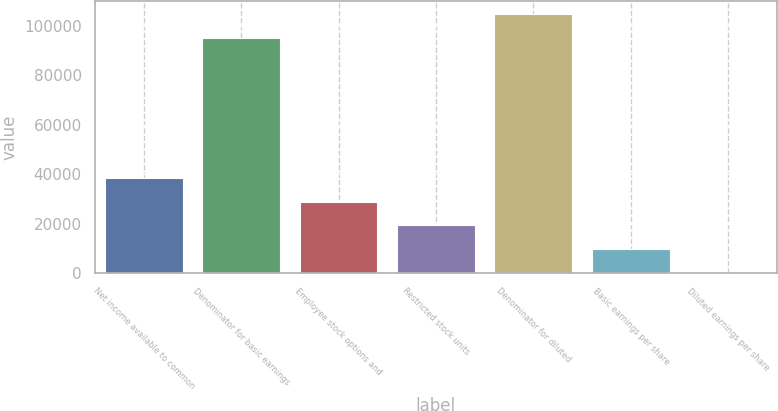<chart> <loc_0><loc_0><loc_500><loc_500><bar_chart><fcel>Net income available to common<fcel>Denominator for basic earnings<fcel>Employee stock options and<fcel>Restricted stock units<fcel>Denominator for diluted<fcel>Basic earnings per share<fcel>Diluted earnings per share<nl><fcel>38555.2<fcel>95170<fcel>28917.9<fcel>19280.7<fcel>104807<fcel>9643.36<fcel>6.07<nl></chart> 